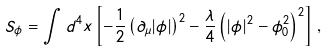<formula> <loc_0><loc_0><loc_500><loc_500>S _ { \phi } = \int d ^ { 4 } x \left [ - \frac { 1 } { 2 } \left ( \partial _ { \mu } | \phi | \right ) ^ { 2 } - \frac { \lambda } { 4 } \left ( | \phi | ^ { 2 } - \phi _ { 0 } ^ { 2 } \right ) ^ { 2 } \right ] \, ,</formula> 